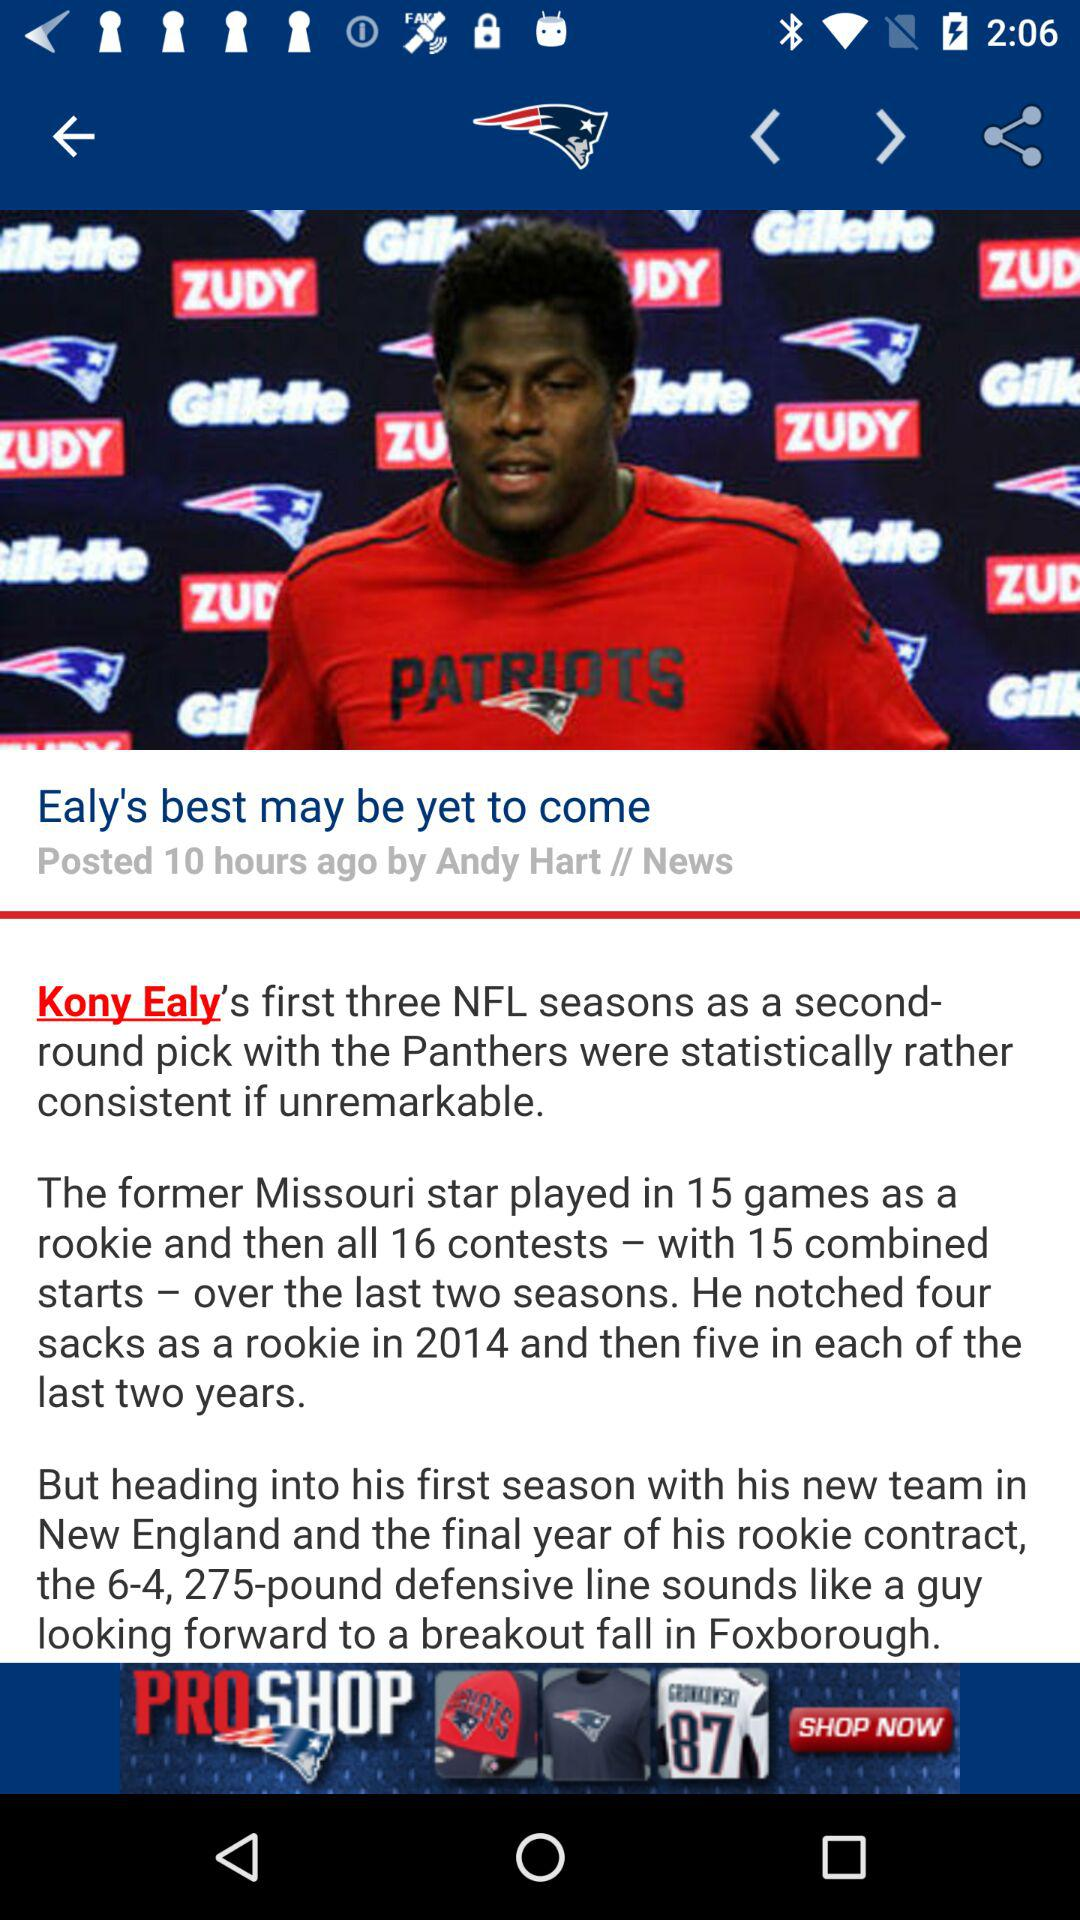When was "Ealy's best may be yet to come" posted? "Ealy's best may be yet to come" was posted 10 hours ago. 